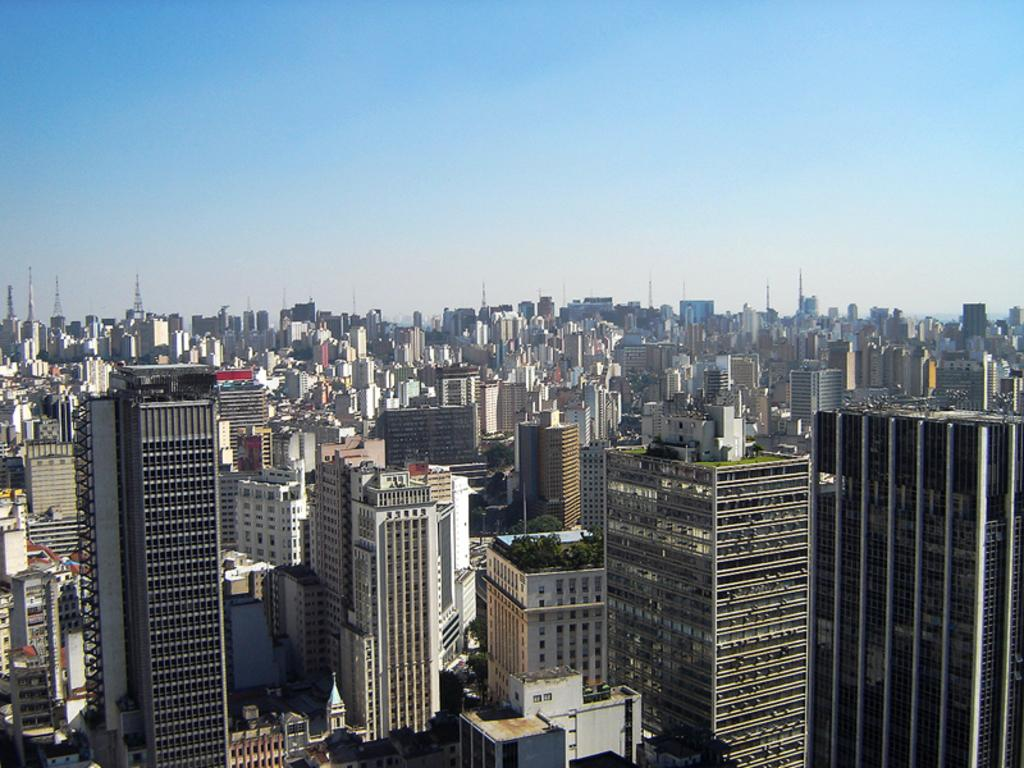What type of structures can be seen in the image? There are buildings in the image. What part of the natural environment is visible in the image? The sky is visible in the background of the image. Where is the shop located in the image? There is no shop mentioned or visible in the image. What is the limit of the square in the image? There is no square mentioned or visible in the image. 